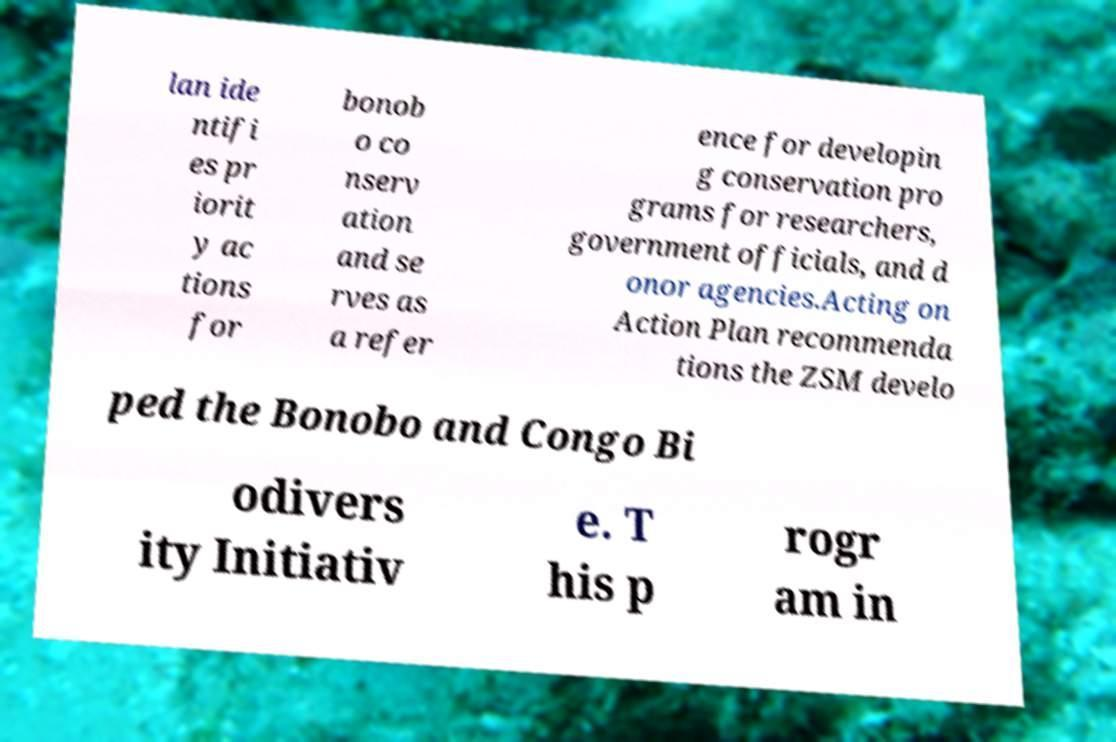What messages or text are displayed in this image? I need them in a readable, typed format. lan ide ntifi es pr iorit y ac tions for bonob o co nserv ation and se rves as a refer ence for developin g conservation pro grams for researchers, government officials, and d onor agencies.Acting on Action Plan recommenda tions the ZSM develo ped the Bonobo and Congo Bi odivers ity Initiativ e. T his p rogr am in 